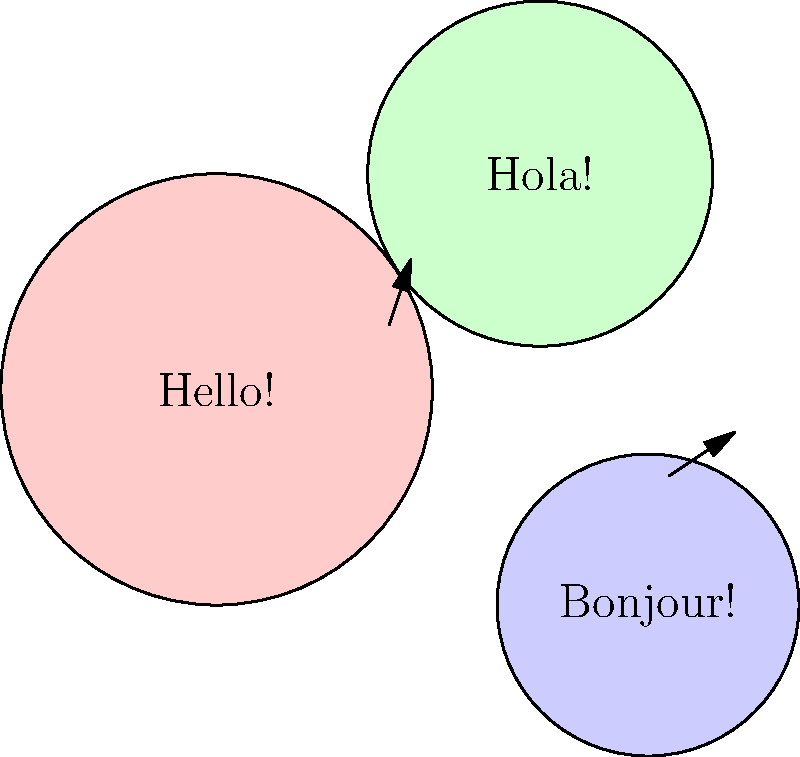In a multilingual narrative, how can color-coded speech bubbles effectively represent language mixing in dialogue? Consider the graphic above and explain the potential benefits and challenges of this approach for storytelling. 1. Visual Representation: The graphic shows three speech bubbles in different colors, each containing a greeting in a different language.

2. Color Coding: Each bubble has a distinct color (pink, green, blue), representing different languages (English, Spanish, French).

3. Benefits:
   a. Immediate visual cue: Readers can quickly identify language changes without explicit mentions.
   b. Enhances immersion: Creates a more engaging reading experience.
   c. Reduces text clutter: Eliminates the need for constant language identification in the narrative.

4. Challenges:
   a. Color consistency: Maintaining consistent colors throughout the story for each language.
   b. Color choice: Selecting colors that are distinguishable and accessible for all readers.
   c. Limited number of languages: Color coding may become confusing with too many languages.

5. Storytelling Impact:
   a. Pacing: Allows for smoother transitions between languages without interrupting the narrative flow.
   b. Character development: Can subtly indicate a character's linguistic background or changes in their language use.
   c. Setting: Helps establish multilingual environments more organically.

6. Implementation:
   a. Legend: Consider including a color key for readers to reference.
   b. Gradients: Could use color gradients for mixed-language sentences or code-switching.
   c. Consistency: Ensure color choices remain consistent throughout the narrative.

7. Accessibility:
   a. Consider colorblind readers: Use patterns or textures in addition to colors.
   b. Digital vs. Print: Ensure colors translate well in both mediums.
Answer: Color-coded speech bubbles visually represent different languages, enhancing readability and immersion while presenting challenges in consistency and accessibility. 